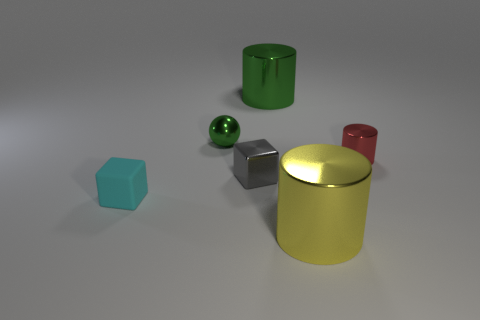Subtract all yellow cylinders. How many cylinders are left? 2 Add 2 big brown shiny cylinders. How many objects exist? 8 Subtract all spheres. How many objects are left? 5 Subtract all yellow matte cylinders. Subtract all cyan blocks. How many objects are left? 5 Add 3 tiny green metallic spheres. How many tiny green metallic spheres are left? 4 Add 4 brown metallic cylinders. How many brown metallic cylinders exist? 4 Subtract 0 blue cylinders. How many objects are left? 6 